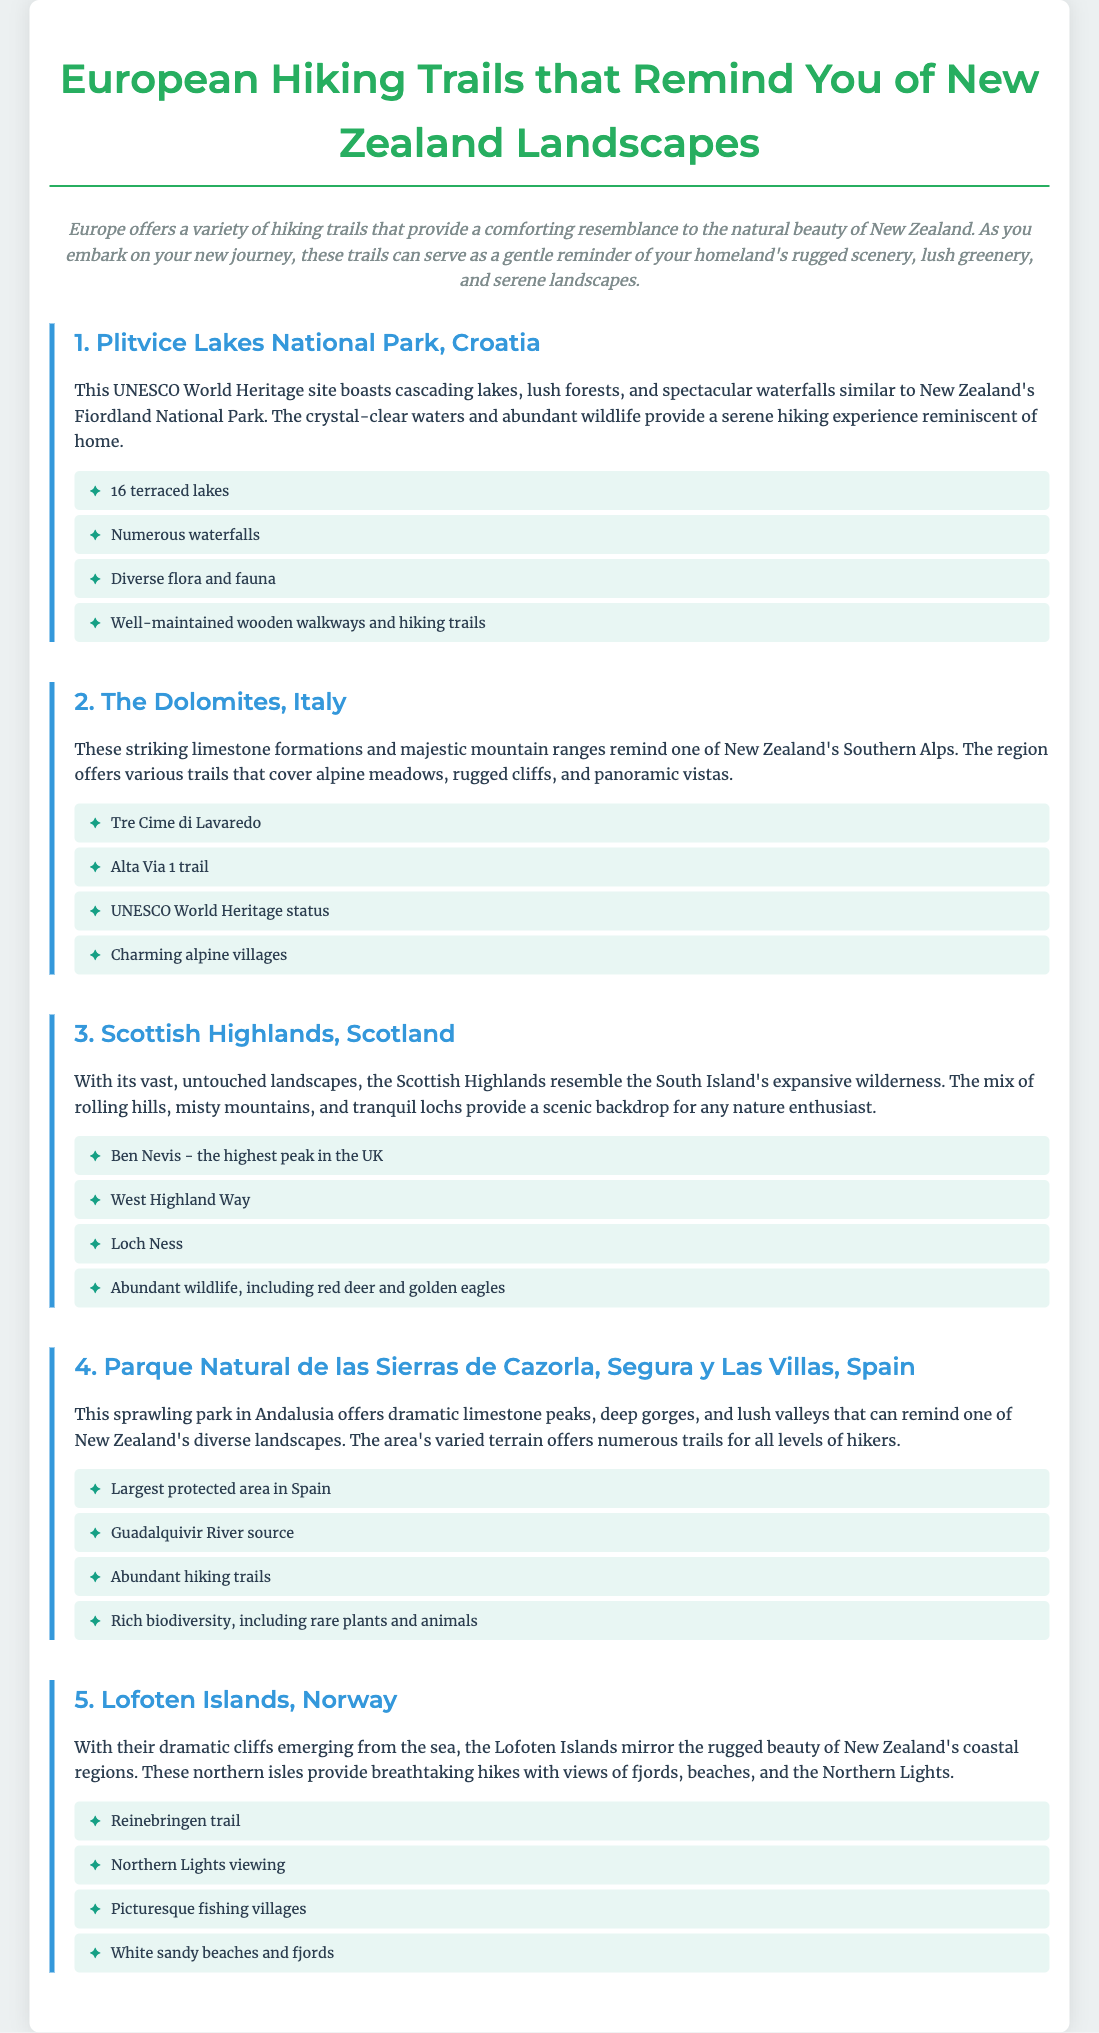what is the first hiking trail mentioned? The first hiking trail listed in the document is Plitvice Lakes National Park in Croatia.
Answer: Plitvice Lakes National Park how many lakes are in Plitvice Lakes National Park? The document states that there are 16 terraced lakes in Plitvice Lakes National Park.
Answer: 16 which country is home to The Dolomites? The document mentions that The Dolomites are located in Italy.
Answer: Italy what is the highest peak in the Scottish Highlands? According to the document, Ben Nevis is the highest peak in the Scottish Highlands.
Answer: Ben Nevis which park is the largest protected area in Spain? The document specifies that Parque Natural de las Sierras de Cazorla, Segura y Las Villas is the largest protected area in Spain.
Answer: Parque Natural de las Sierras de Cazorla, Segura y Las Villas what natural feature do the Lofoten Islands share with New Zealand? The Lofoten Islands have dramatic cliffs emerging from the sea, similar to those found in New Zealand's coastal regions.
Answer: Dramatic cliffs which trail in Scotland is mentioned for hikers? The document highlights the West Highland Way as a notable trail in the Scottish Highlands.
Answer: West Highland Way how many features are listed for The Dolomites? The document lists four features for The Dolomites.
Answer: 4 what type of park is Parque Natural de las Sierras de Cazorla? The document describes it as a sprawling natural park in Andalusia.
Answer: Natural park 